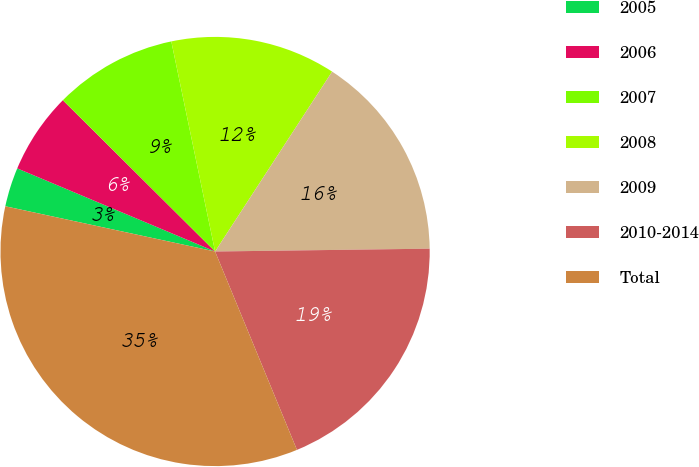Convert chart. <chart><loc_0><loc_0><loc_500><loc_500><pie_chart><fcel>2005<fcel>2006<fcel>2007<fcel>2008<fcel>2009<fcel>2010-2014<fcel>Total<nl><fcel>2.95%<fcel>6.12%<fcel>9.28%<fcel>12.45%<fcel>15.61%<fcel>18.98%<fcel>34.61%<nl></chart> 